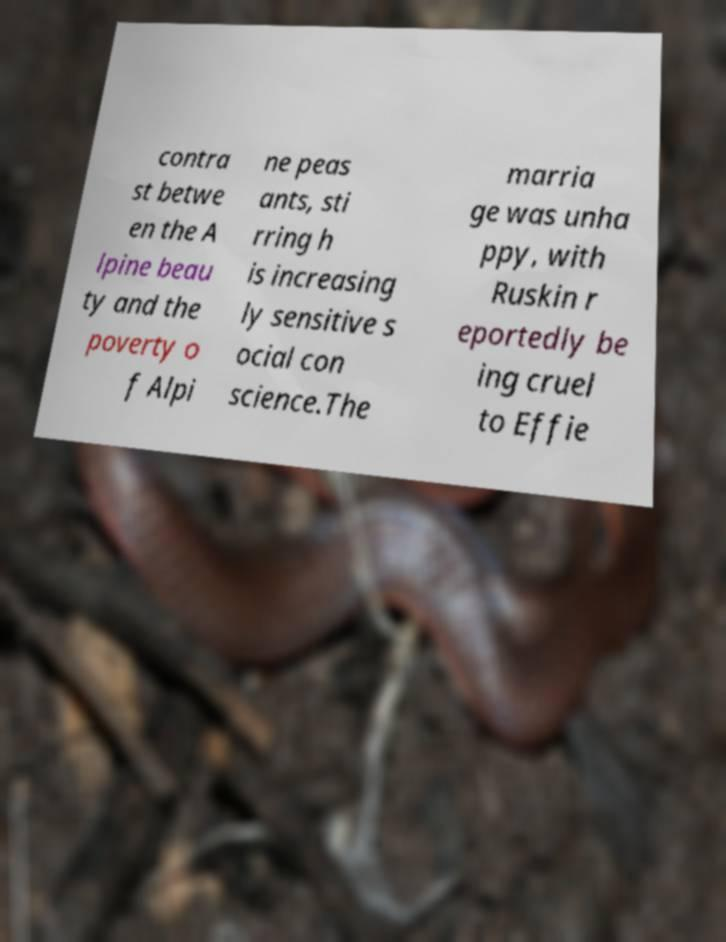For documentation purposes, I need the text within this image transcribed. Could you provide that? contra st betwe en the A lpine beau ty and the poverty o f Alpi ne peas ants, sti rring h is increasing ly sensitive s ocial con science.The marria ge was unha ppy, with Ruskin r eportedly be ing cruel to Effie 